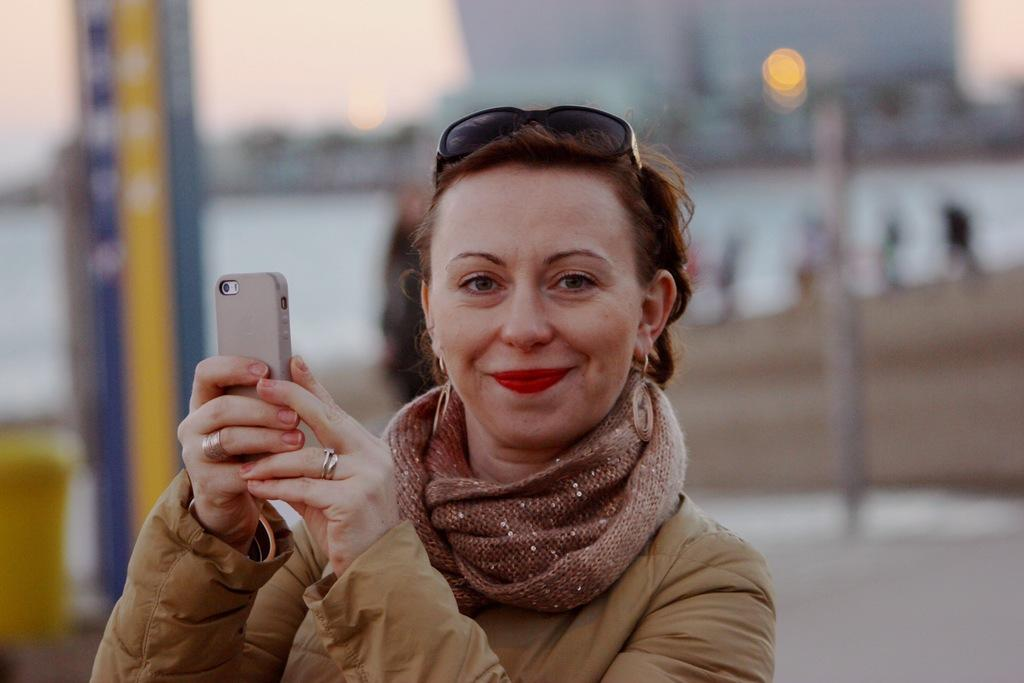Who is present in the image? There is a woman in the image. What is the woman holding in the image? The woman is holding a mobile. What is the woman's facial expression in the image? The woman is smiling in the image. What accessory is the woman wearing on her head? The woman has glasses on her head. Can you describe the background of the image? The background of the image is blurry. What type of stem can be seen growing from the woman's hair in the image? There is no stem growing from the woman's hair in the image. Can you describe the cobweb that is present in the woman's ear in the image? There is no cobweb present in the woman's ear in the image. 